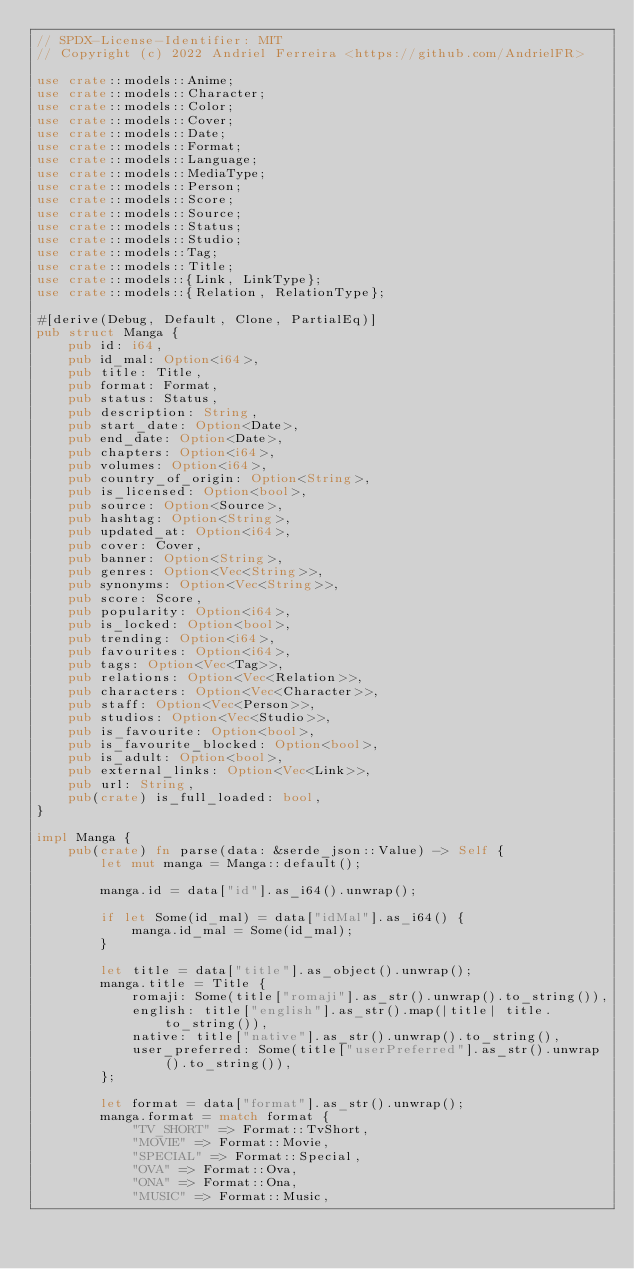<code> <loc_0><loc_0><loc_500><loc_500><_Rust_>// SPDX-License-Identifier: MIT
// Copyright (c) 2022 Andriel Ferreira <https://github.com/AndrielFR>

use crate::models::Anime;
use crate::models::Character;
use crate::models::Color;
use crate::models::Cover;
use crate::models::Date;
use crate::models::Format;
use crate::models::Language;
use crate::models::MediaType;
use crate::models::Person;
use crate::models::Score;
use crate::models::Source;
use crate::models::Status;
use crate::models::Studio;
use crate::models::Tag;
use crate::models::Title;
use crate::models::{Link, LinkType};
use crate::models::{Relation, RelationType};

#[derive(Debug, Default, Clone, PartialEq)]
pub struct Manga {
    pub id: i64,
    pub id_mal: Option<i64>,
    pub title: Title,
    pub format: Format,
    pub status: Status,
    pub description: String,
    pub start_date: Option<Date>,
    pub end_date: Option<Date>,
    pub chapters: Option<i64>,
    pub volumes: Option<i64>,
    pub country_of_origin: Option<String>,
    pub is_licensed: Option<bool>,
    pub source: Option<Source>,
    pub hashtag: Option<String>,
    pub updated_at: Option<i64>,
    pub cover: Cover,
    pub banner: Option<String>,
    pub genres: Option<Vec<String>>,
    pub synonyms: Option<Vec<String>>,
    pub score: Score,
    pub popularity: Option<i64>,
    pub is_locked: Option<bool>,
    pub trending: Option<i64>,
    pub favourites: Option<i64>,
    pub tags: Option<Vec<Tag>>,
    pub relations: Option<Vec<Relation>>,
    pub characters: Option<Vec<Character>>,
    pub staff: Option<Vec<Person>>,
    pub studios: Option<Vec<Studio>>,
    pub is_favourite: Option<bool>,
    pub is_favourite_blocked: Option<bool>,
    pub is_adult: Option<bool>,
    pub external_links: Option<Vec<Link>>,
    pub url: String,
    pub(crate) is_full_loaded: bool,
}

impl Manga {
    pub(crate) fn parse(data: &serde_json::Value) -> Self {
        let mut manga = Manga::default();

        manga.id = data["id"].as_i64().unwrap();

        if let Some(id_mal) = data["idMal"].as_i64() {
            manga.id_mal = Some(id_mal);
        }

        let title = data["title"].as_object().unwrap();
        manga.title = Title {
            romaji: Some(title["romaji"].as_str().unwrap().to_string()),
            english: title["english"].as_str().map(|title| title.to_string()),
            native: title["native"].as_str().unwrap().to_string(),
            user_preferred: Some(title["userPreferred"].as_str().unwrap().to_string()),
        };

        let format = data["format"].as_str().unwrap();
        manga.format = match format {
            "TV_SHORT" => Format::TvShort,
            "MOVIE" => Format::Movie,
            "SPECIAL" => Format::Special,
            "OVA" => Format::Ova,
            "ONA" => Format::Ona,
            "MUSIC" => Format::Music,</code> 